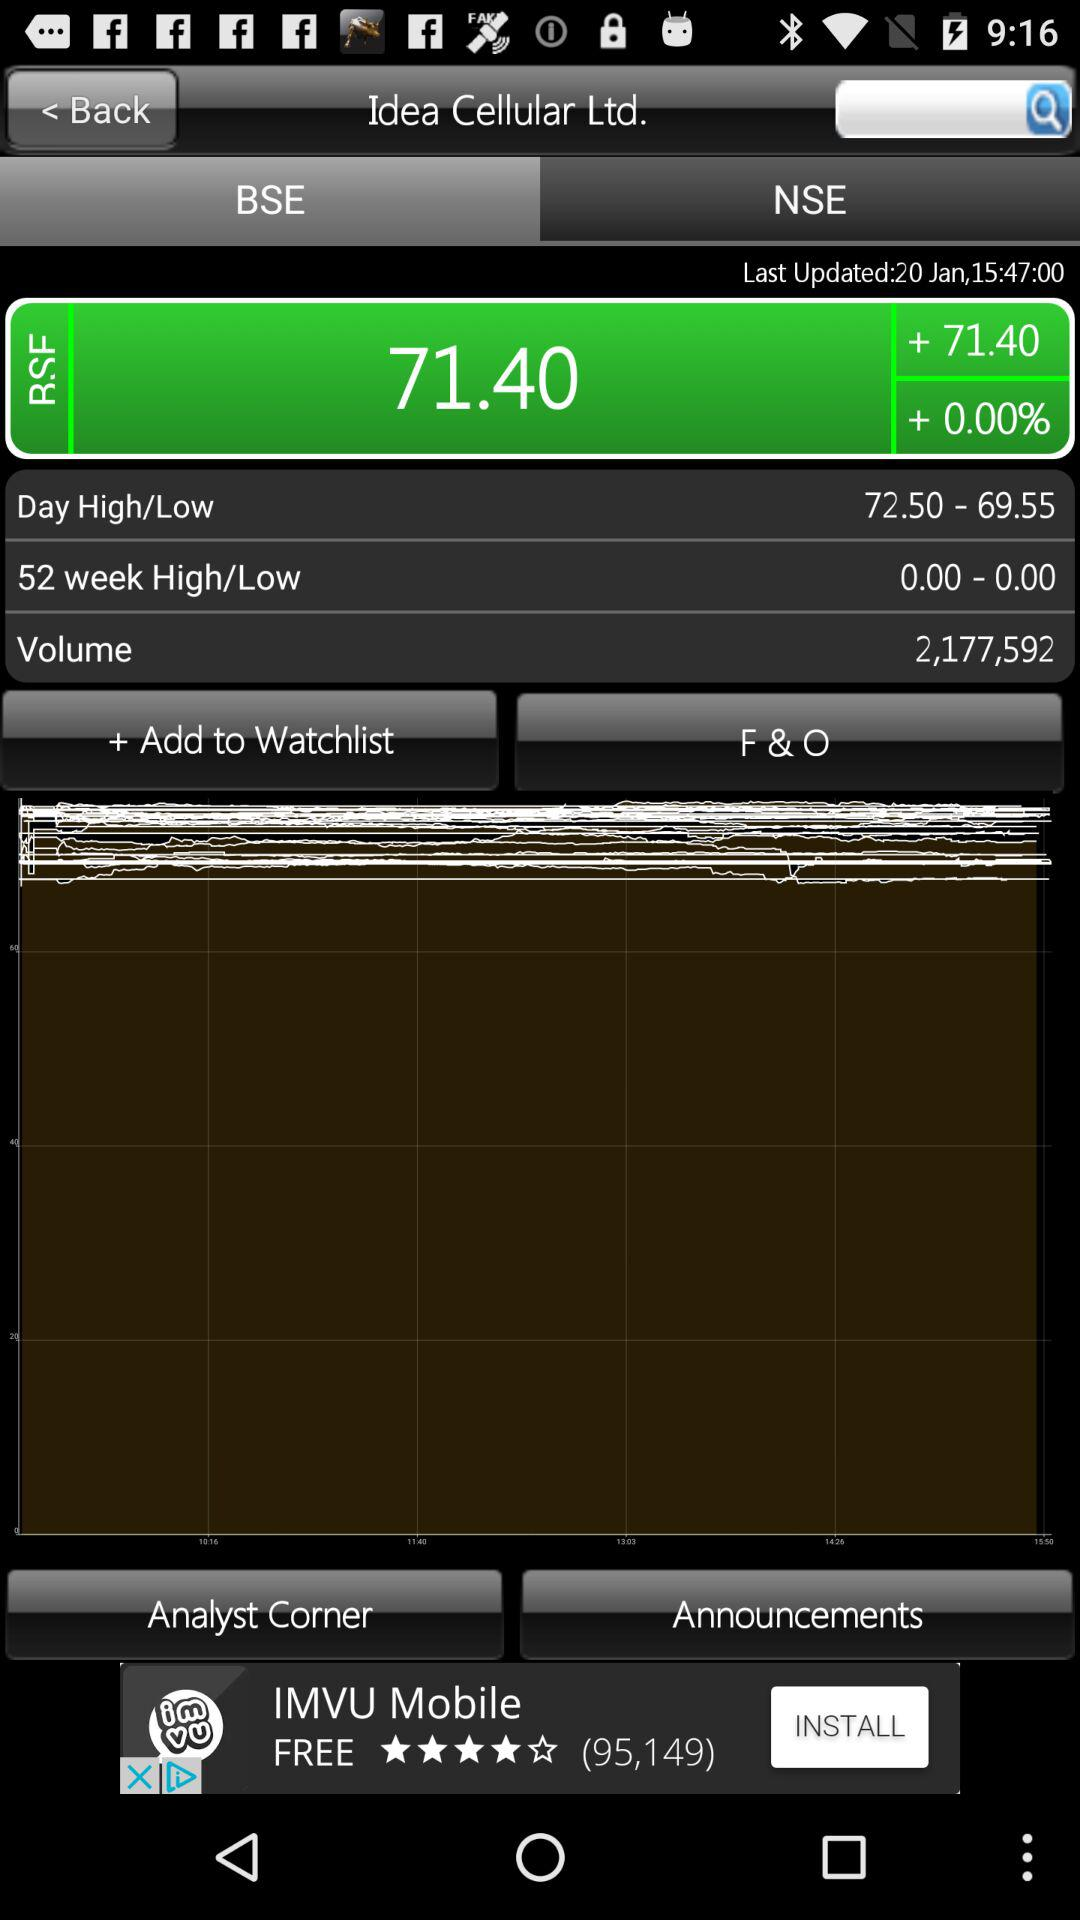What is the total percentage change of "Idea Cellular Ltd." in BSE? The total percentage change of "Idea Cellular Ltd." in BSE is 0. 